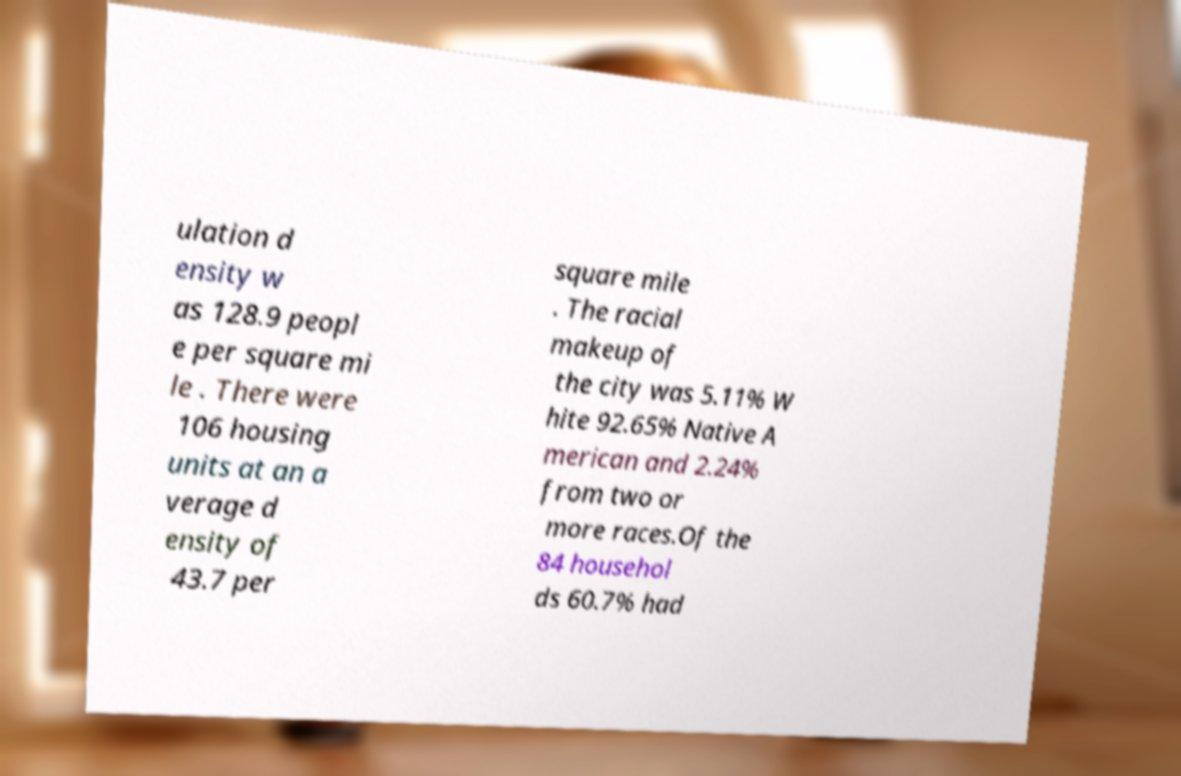Could you extract and type out the text from this image? ulation d ensity w as 128.9 peopl e per square mi le . There were 106 housing units at an a verage d ensity of 43.7 per square mile . The racial makeup of the city was 5.11% W hite 92.65% Native A merican and 2.24% from two or more races.Of the 84 househol ds 60.7% had 